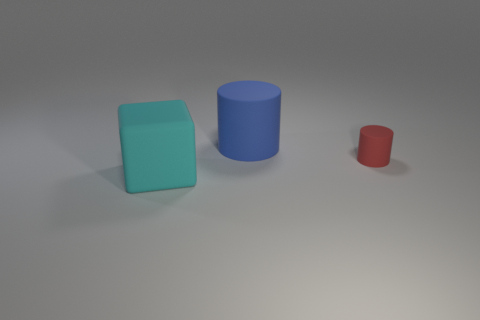Is the shape of the blue matte object the same as the matte thing in front of the red thing?
Your answer should be compact. No. How many objects are matte blocks or gray metal cubes?
Provide a short and direct response. 1. What shape is the matte object that is left of the large rubber object that is behind the rubber cube?
Give a very brief answer. Cube. Do the big matte thing behind the tiny red matte object and the red thing have the same shape?
Offer a very short reply. Yes. The red thing that is made of the same material as the large blue thing is what size?
Your response must be concise. Small. What number of objects are matte things behind the small red cylinder or large matte objects that are right of the cube?
Make the answer very short. 1. Is the number of cyan rubber blocks to the left of the matte block the same as the number of cylinders on the left side of the small rubber thing?
Keep it short and to the point. No. There is a big rubber object that is right of the matte cube; what color is it?
Ensure brevity in your answer.  Blue. There is a small cylinder; does it have the same color as the rubber thing left of the large blue object?
Provide a succinct answer. No. Are there fewer tiny red cylinders than big red rubber blocks?
Make the answer very short. No. 